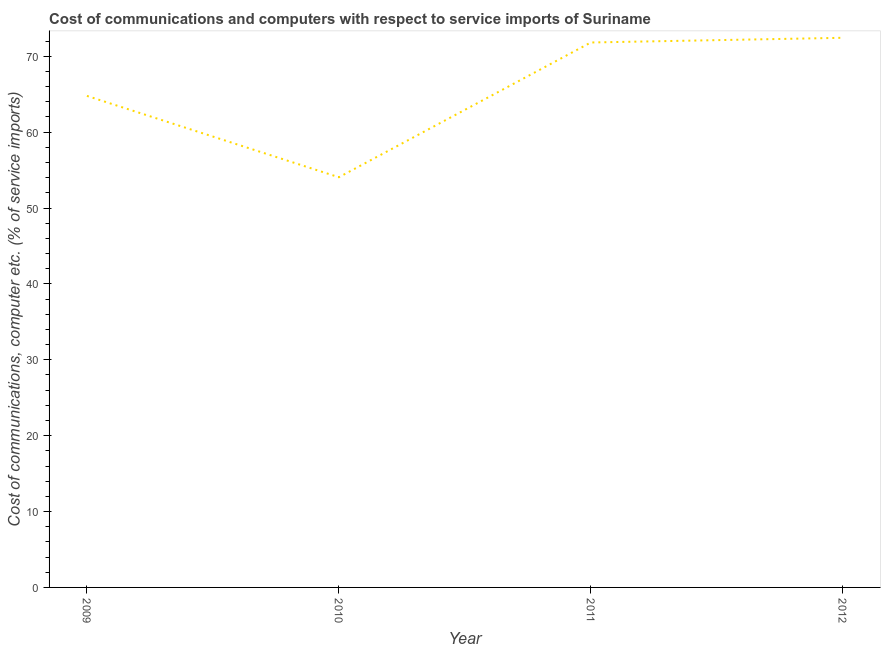What is the cost of communications and computer in 2012?
Keep it short and to the point. 72.43. Across all years, what is the maximum cost of communications and computer?
Provide a short and direct response. 72.43. Across all years, what is the minimum cost of communications and computer?
Ensure brevity in your answer.  54.05. In which year was the cost of communications and computer minimum?
Make the answer very short. 2010. What is the sum of the cost of communications and computer?
Provide a succinct answer. 263.07. What is the difference between the cost of communications and computer in 2010 and 2012?
Your answer should be compact. -18.38. What is the average cost of communications and computer per year?
Provide a short and direct response. 65.77. What is the median cost of communications and computer?
Your response must be concise. 68.29. In how many years, is the cost of communications and computer greater than 30 %?
Your answer should be compact. 4. What is the ratio of the cost of communications and computer in 2011 to that in 2012?
Ensure brevity in your answer.  0.99. Is the cost of communications and computer in 2010 less than that in 2012?
Offer a terse response. Yes. Is the difference between the cost of communications and computer in 2009 and 2012 greater than the difference between any two years?
Give a very brief answer. No. What is the difference between the highest and the second highest cost of communications and computer?
Keep it short and to the point. 0.62. Is the sum of the cost of communications and computer in 2009 and 2011 greater than the maximum cost of communications and computer across all years?
Keep it short and to the point. Yes. What is the difference between the highest and the lowest cost of communications and computer?
Provide a succinct answer. 18.38. In how many years, is the cost of communications and computer greater than the average cost of communications and computer taken over all years?
Provide a short and direct response. 2. How many lines are there?
Make the answer very short. 1. What is the difference between two consecutive major ticks on the Y-axis?
Keep it short and to the point. 10. Are the values on the major ticks of Y-axis written in scientific E-notation?
Keep it short and to the point. No. Does the graph contain any zero values?
Give a very brief answer. No. What is the title of the graph?
Give a very brief answer. Cost of communications and computers with respect to service imports of Suriname. What is the label or title of the Y-axis?
Your answer should be compact. Cost of communications, computer etc. (% of service imports). What is the Cost of communications, computer etc. (% of service imports) in 2009?
Give a very brief answer. 64.77. What is the Cost of communications, computer etc. (% of service imports) of 2010?
Provide a succinct answer. 54.05. What is the Cost of communications, computer etc. (% of service imports) of 2011?
Keep it short and to the point. 71.81. What is the Cost of communications, computer etc. (% of service imports) of 2012?
Ensure brevity in your answer.  72.43. What is the difference between the Cost of communications, computer etc. (% of service imports) in 2009 and 2010?
Your response must be concise. 10.72. What is the difference between the Cost of communications, computer etc. (% of service imports) in 2009 and 2011?
Keep it short and to the point. -7.04. What is the difference between the Cost of communications, computer etc. (% of service imports) in 2009 and 2012?
Provide a succinct answer. -7.66. What is the difference between the Cost of communications, computer etc. (% of service imports) in 2010 and 2011?
Your answer should be very brief. -17.76. What is the difference between the Cost of communications, computer etc. (% of service imports) in 2010 and 2012?
Offer a very short reply. -18.38. What is the difference between the Cost of communications, computer etc. (% of service imports) in 2011 and 2012?
Your response must be concise. -0.62. What is the ratio of the Cost of communications, computer etc. (% of service imports) in 2009 to that in 2010?
Give a very brief answer. 1.2. What is the ratio of the Cost of communications, computer etc. (% of service imports) in 2009 to that in 2011?
Keep it short and to the point. 0.9. What is the ratio of the Cost of communications, computer etc. (% of service imports) in 2009 to that in 2012?
Your response must be concise. 0.89. What is the ratio of the Cost of communications, computer etc. (% of service imports) in 2010 to that in 2011?
Provide a succinct answer. 0.75. What is the ratio of the Cost of communications, computer etc. (% of service imports) in 2010 to that in 2012?
Provide a short and direct response. 0.75. What is the ratio of the Cost of communications, computer etc. (% of service imports) in 2011 to that in 2012?
Keep it short and to the point. 0.99. 